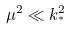Convert formula to latex. <formula><loc_0><loc_0><loc_500><loc_500>\mu ^ { 2 } \ll k _ { ^ { * } } ^ { 2 }</formula> 